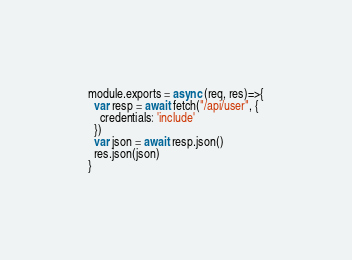Convert code to text. <code><loc_0><loc_0><loc_500><loc_500><_JavaScript_>module.exports = async (req, res)=>{
  var resp = await fetch("/api/user", {
    credentials: 'include'
  })
  var json = await resp.json()
  res.json(json)
}</code> 